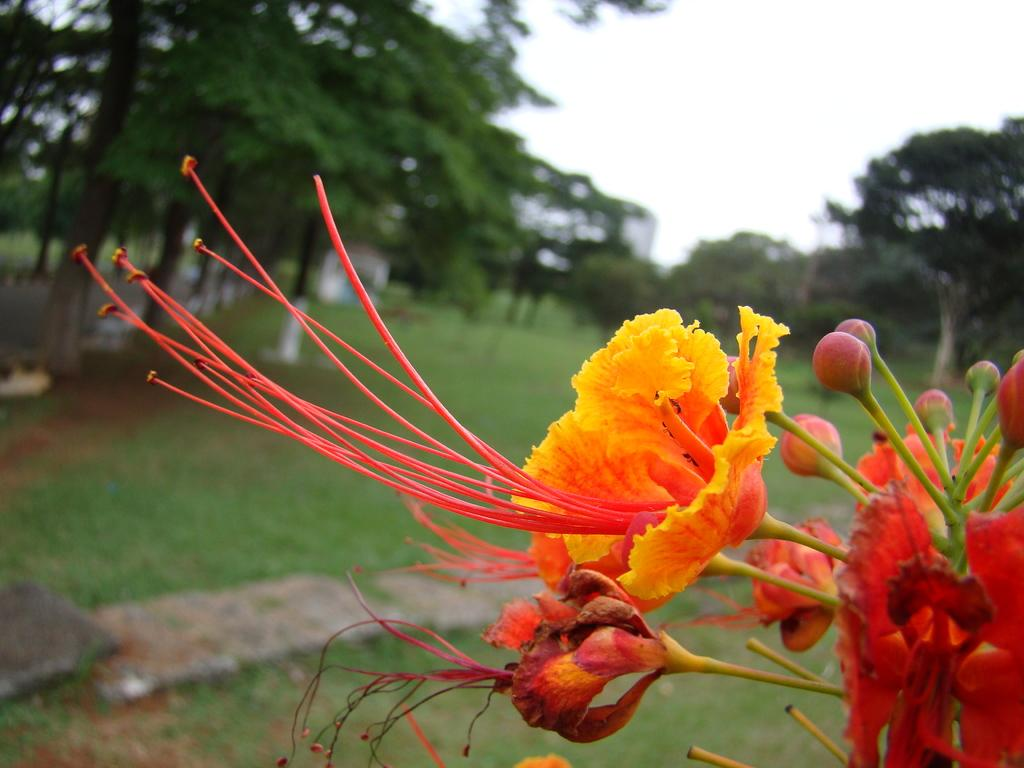What type of plant is featured in the image? There is a plant with flowers and buds in the image. What can be seen in the background of the image? There is a house, trees, plants, and grass in the background of the image. What part of the sky is visible in the image? The sky is visible in the top right of the image. What type of action is the paper performing in the image? There is no paper present in the image, so it cannot perform any actions. 